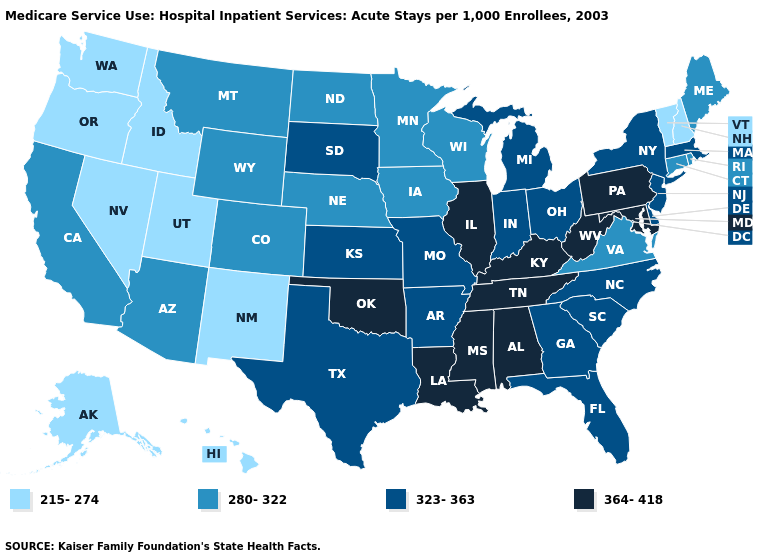What is the value of Illinois?
Quick response, please. 364-418. What is the value of New Hampshire?
Answer briefly. 215-274. Name the states that have a value in the range 280-322?
Concise answer only. Arizona, California, Colorado, Connecticut, Iowa, Maine, Minnesota, Montana, Nebraska, North Dakota, Rhode Island, Virginia, Wisconsin, Wyoming. Among the states that border Texas , which have the lowest value?
Answer briefly. New Mexico. Name the states that have a value in the range 280-322?
Concise answer only. Arizona, California, Colorado, Connecticut, Iowa, Maine, Minnesota, Montana, Nebraska, North Dakota, Rhode Island, Virginia, Wisconsin, Wyoming. Among the states that border Utah , which have the lowest value?
Keep it brief. Idaho, Nevada, New Mexico. Which states have the lowest value in the USA?
Quick response, please. Alaska, Hawaii, Idaho, Nevada, New Hampshire, New Mexico, Oregon, Utah, Vermont, Washington. Among the states that border Wyoming , which have the lowest value?
Keep it brief. Idaho, Utah. Among the states that border Mississippi , which have the lowest value?
Concise answer only. Arkansas. What is the lowest value in the West?
Keep it brief. 215-274. Does Delaware have the lowest value in the South?
Concise answer only. No. Among the states that border Wyoming , does South Dakota have the highest value?
Write a very short answer. Yes. Name the states that have a value in the range 364-418?
Answer briefly. Alabama, Illinois, Kentucky, Louisiana, Maryland, Mississippi, Oklahoma, Pennsylvania, Tennessee, West Virginia. Name the states that have a value in the range 364-418?
Be succinct. Alabama, Illinois, Kentucky, Louisiana, Maryland, Mississippi, Oklahoma, Pennsylvania, Tennessee, West Virginia. 